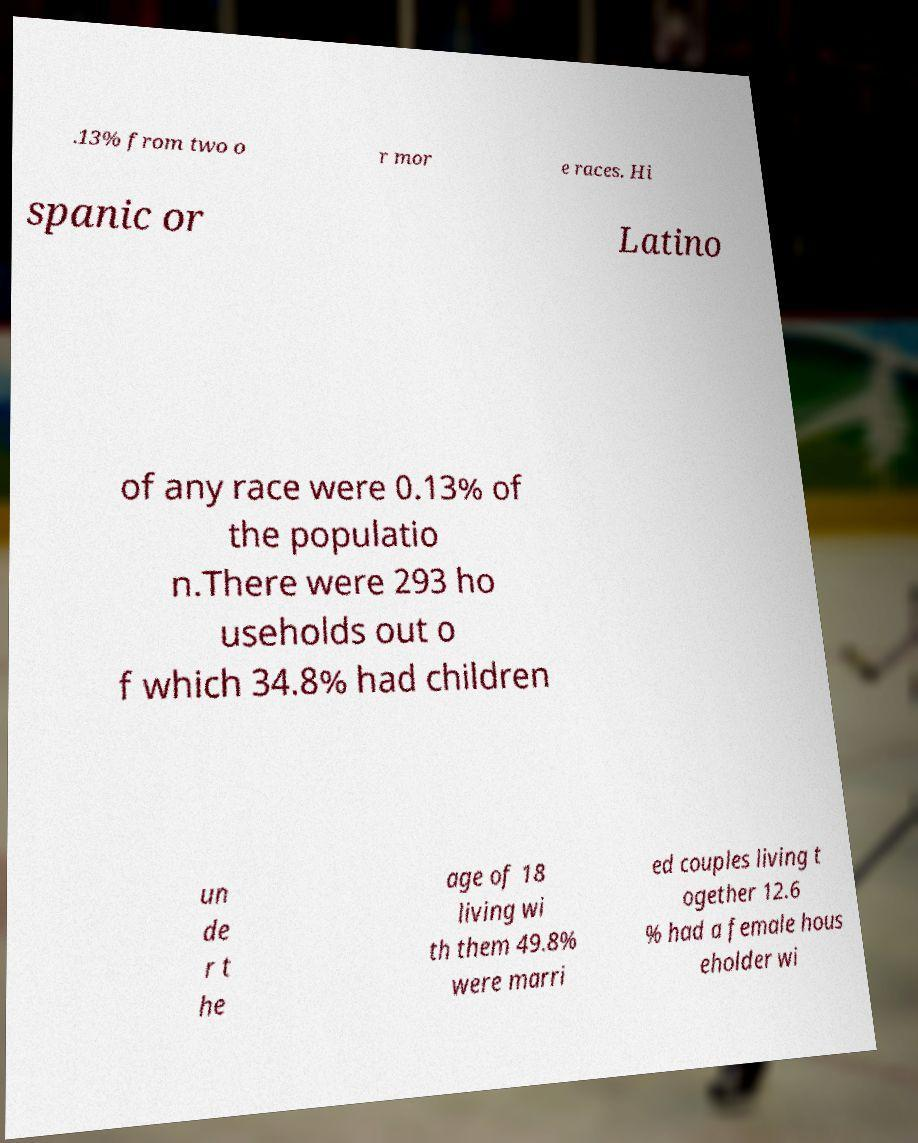I need the written content from this picture converted into text. Can you do that? .13% from two o r mor e races. Hi spanic or Latino of any race were 0.13% of the populatio n.There were 293 ho useholds out o f which 34.8% had children un de r t he age of 18 living wi th them 49.8% were marri ed couples living t ogether 12.6 % had a female hous eholder wi 